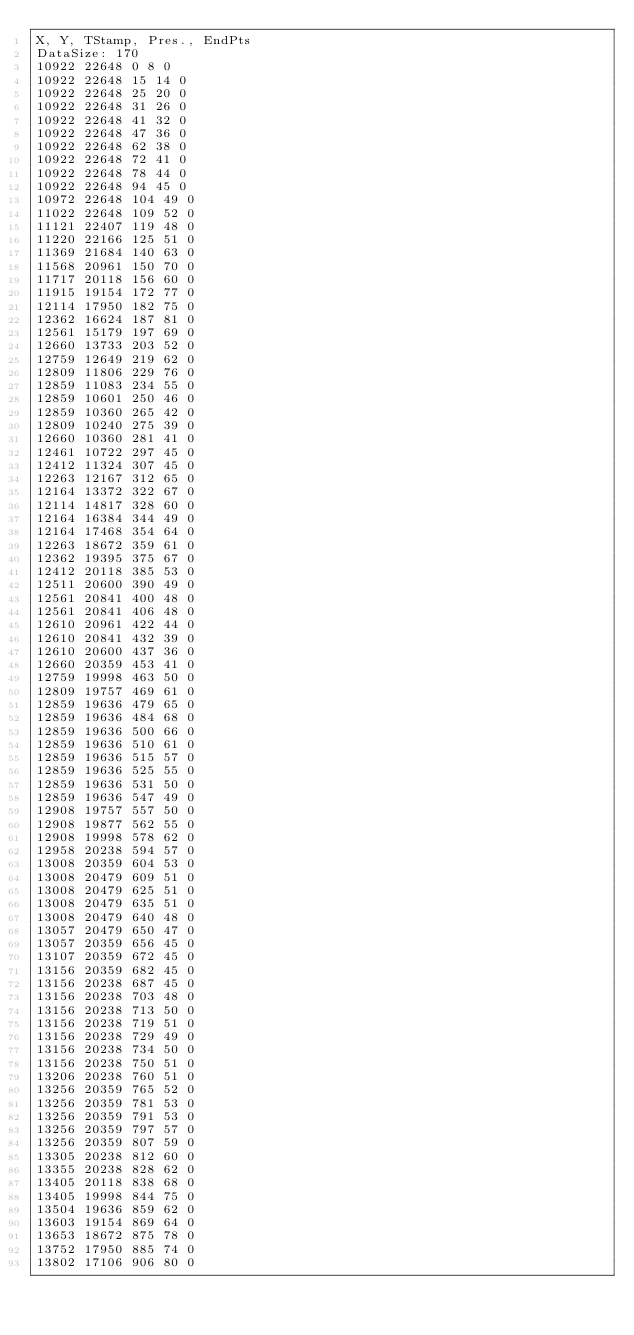<code> <loc_0><loc_0><loc_500><loc_500><_SML_>X, Y, TStamp, Pres., EndPts
DataSize: 170
10922 22648 0 8 0
10922 22648 15 14 0
10922 22648 25 20 0
10922 22648 31 26 0
10922 22648 41 32 0
10922 22648 47 36 0
10922 22648 62 38 0
10922 22648 72 41 0
10922 22648 78 44 0
10922 22648 94 45 0
10972 22648 104 49 0
11022 22648 109 52 0
11121 22407 119 48 0
11220 22166 125 51 0
11369 21684 140 63 0
11568 20961 150 70 0
11717 20118 156 60 0
11915 19154 172 77 0
12114 17950 182 75 0
12362 16624 187 81 0
12561 15179 197 69 0
12660 13733 203 52 0
12759 12649 219 62 0
12809 11806 229 76 0
12859 11083 234 55 0
12859 10601 250 46 0
12859 10360 265 42 0
12809 10240 275 39 0
12660 10360 281 41 0
12461 10722 297 45 0
12412 11324 307 45 0
12263 12167 312 65 0
12164 13372 322 67 0
12114 14817 328 60 0
12164 16384 344 49 0
12164 17468 354 64 0
12263 18672 359 61 0
12362 19395 375 67 0
12412 20118 385 53 0
12511 20600 390 49 0
12561 20841 400 48 0
12561 20841 406 48 0
12610 20961 422 44 0
12610 20841 432 39 0
12610 20600 437 36 0
12660 20359 453 41 0
12759 19998 463 50 0
12809 19757 469 61 0
12859 19636 479 65 0
12859 19636 484 68 0
12859 19636 500 66 0
12859 19636 510 61 0
12859 19636 515 57 0
12859 19636 525 55 0
12859 19636 531 50 0
12859 19636 547 49 0
12908 19757 557 50 0
12908 19877 562 55 0
12908 19998 578 62 0
12958 20238 594 57 0
13008 20359 604 53 0
13008 20479 609 51 0
13008 20479 625 51 0
13008 20479 635 51 0
13008 20479 640 48 0
13057 20479 650 47 0
13057 20359 656 45 0
13107 20359 672 45 0
13156 20359 682 45 0
13156 20238 687 45 0
13156 20238 703 48 0
13156 20238 713 50 0
13156 20238 719 51 0
13156 20238 729 49 0
13156 20238 734 50 0
13156 20238 750 51 0
13206 20238 760 51 0
13256 20359 765 52 0
13256 20359 781 53 0
13256 20359 791 53 0
13256 20359 797 57 0
13256 20359 807 59 0
13305 20238 812 60 0
13355 20238 828 62 0
13405 20118 838 68 0
13405 19998 844 75 0
13504 19636 859 62 0
13603 19154 869 64 0
13653 18672 875 78 0
13752 17950 885 74 0
13802 17106 906 80 0</code> 